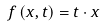<formula> <loc_0><loc_0><loc_500><loc_500>f \left ( x , t \right ) = t \cdot x</formula> 